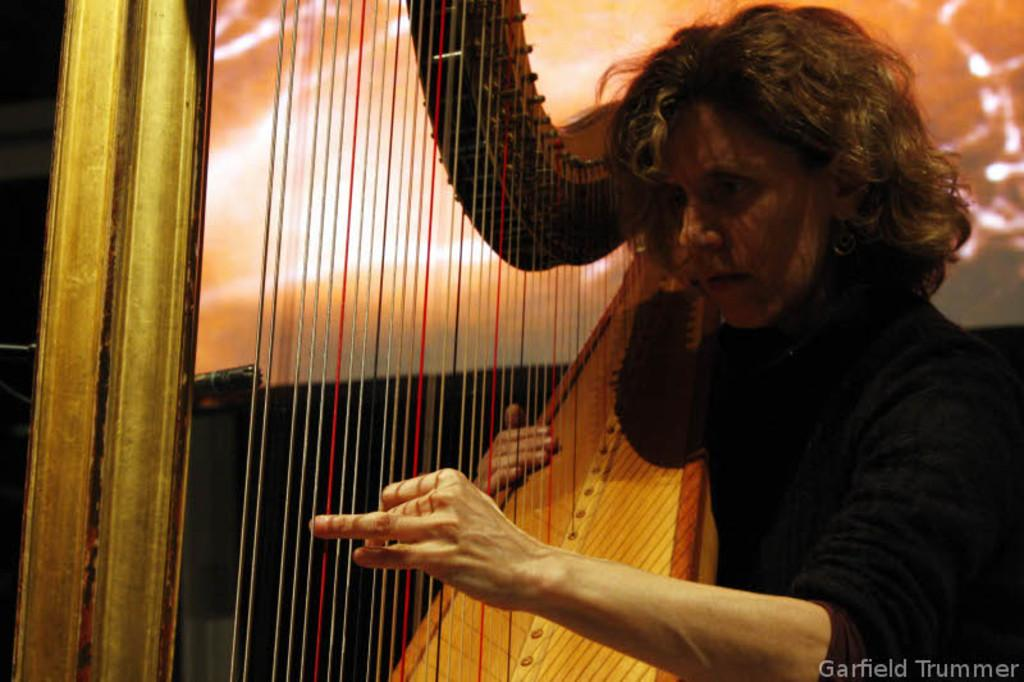What is the main subject of the image? The main subject of the image is a woman. What is the woman holding in her hands? The woman is holding a musical instrument in her hands. What type of religious symbol can be seen on the quilt in the image? There is no quilt or religious symbol present in the image. 